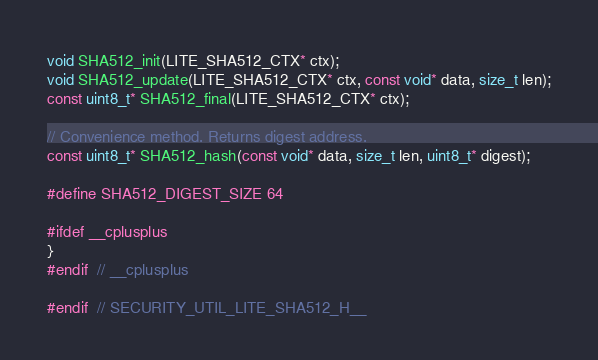<code> <loc_0><loc_0><loc_500><loc_500><_C_>void SHA512_init(LITE_SHA512_CTX* ctx);
void SHA512_update(LITE_SHA512_CTX* ctx, const void* data, size_t len);
const uint8_t* SHA512_final(LITE_SHA512_CTX* ctx);

// Convenience method. Returns digest address.
const uint8_t* SHA512_hash(const void* data, size_t len, uint8_t* digest);

#define SHA512_DIGEST_SIZE 64

#ifdef __cplusplus
}
#endif  // __cplusplus

#endif  // SECURITY_UTIL_LITE_SHA512_H__
</code> 